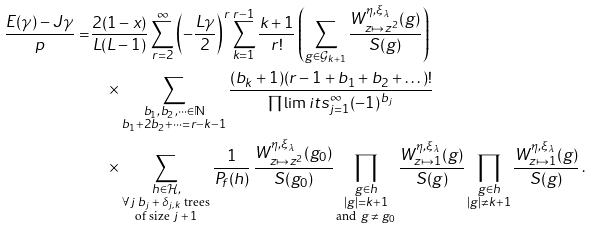Convert formula to latex. <formula><loc_0><loc_0><loc_500><loc_500>\frac { E ( \gamma ) - J \gamma } { p } = & \frac { 2 ( 1 - x ) } { L ( L - 1 ) } \sum _ { r = 2 } ^ { \infty } \left ( - \frac { L \gamma } { 2 } \right ) ^ { r } \sum _ { k = 1 } ^ { r - 1 } \frac { k + 1 } { r ! } \left ( \sum _ { g \in \mathcal { G } _ { k + 1 } } \frac { W _ { z \mapsto z ^ { 2 } } ^ { \eta , \xi _ { \lambda } } ( g ) } { S ( g ) } \right ) \\ & \quad \times \sum _ { \substack { b _ { 1 } , b _ { 2 } , \dots \in \mathbb { N } \\ b _ { 1 } + 2 b _ { 2 } + \dots = r - k - 1 } } \frac { ( b _ { k } + 1 ) ( r - 1 + b _ { 1 } + b _ { 2 } + \dots ) ! } { \prod \lim i t s _ { j = 1 } ^ { \infty } ( - 1 ) ^ { b _ { j } } } \\ & \quad \times \sum _ { \substack { h \in \mathcal { H } , \\ \text {$\forall j$ $b_{j}+\delta_{j,k}$ trees} \\ \text {of size $j+1$} } } \frac { 1 } { P _ { f } ( h ) } \, \frac { W _ { z \mapsto z ^ { 2 } } ^ { \eta , \xi _ { \lambda } } ( g _ { 0 } ) } { S ( g _ { 0 } ) } \prod _ { \substack { g \in h \\ | g | = k + 1 \\ \text {and $g\neq g_{0}$} } } \frac { W _ { z \mapsto 1 } ^ { \eta , \xi _ { \lambda } } ( g ) } { S ( g ) } \prod _ { \substack { g \in h \\ | g | \neq k + 1 } } \frac { W _ { z \mapsto 1 } ^ { \eta , \xi _ { \lambda } } ( g ) } { S ( g ) } \, .</formula> 